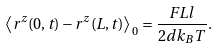Convert formula to latex. <formula><loc_0><loc_0><loc_500><loc_500>\left \langle r ^ { z } ( 0 , t ) - r ^ { z } ( L , t ) \right \rangle _ { \, 0 } = \frac { F L l } { 2 d k _ { B } T } .</formula> 